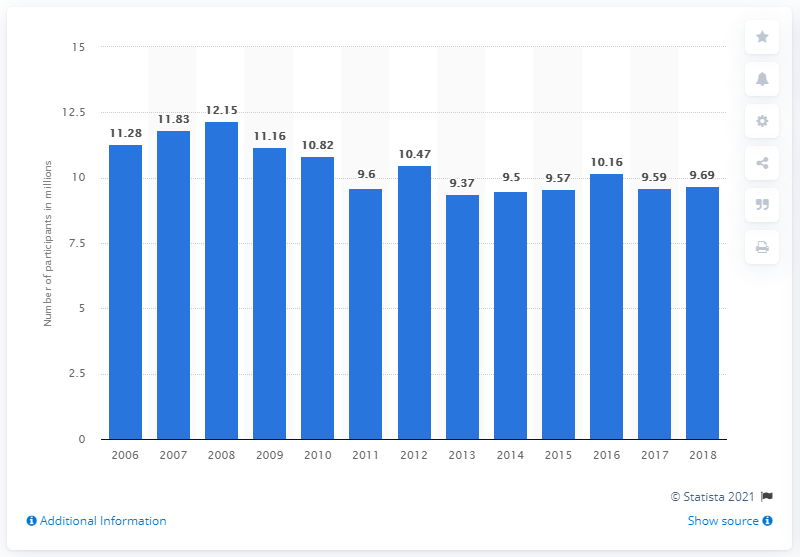Draw attention to some important aspects in this diagram. There were a total of 9,695 participants in softball in 2018. 